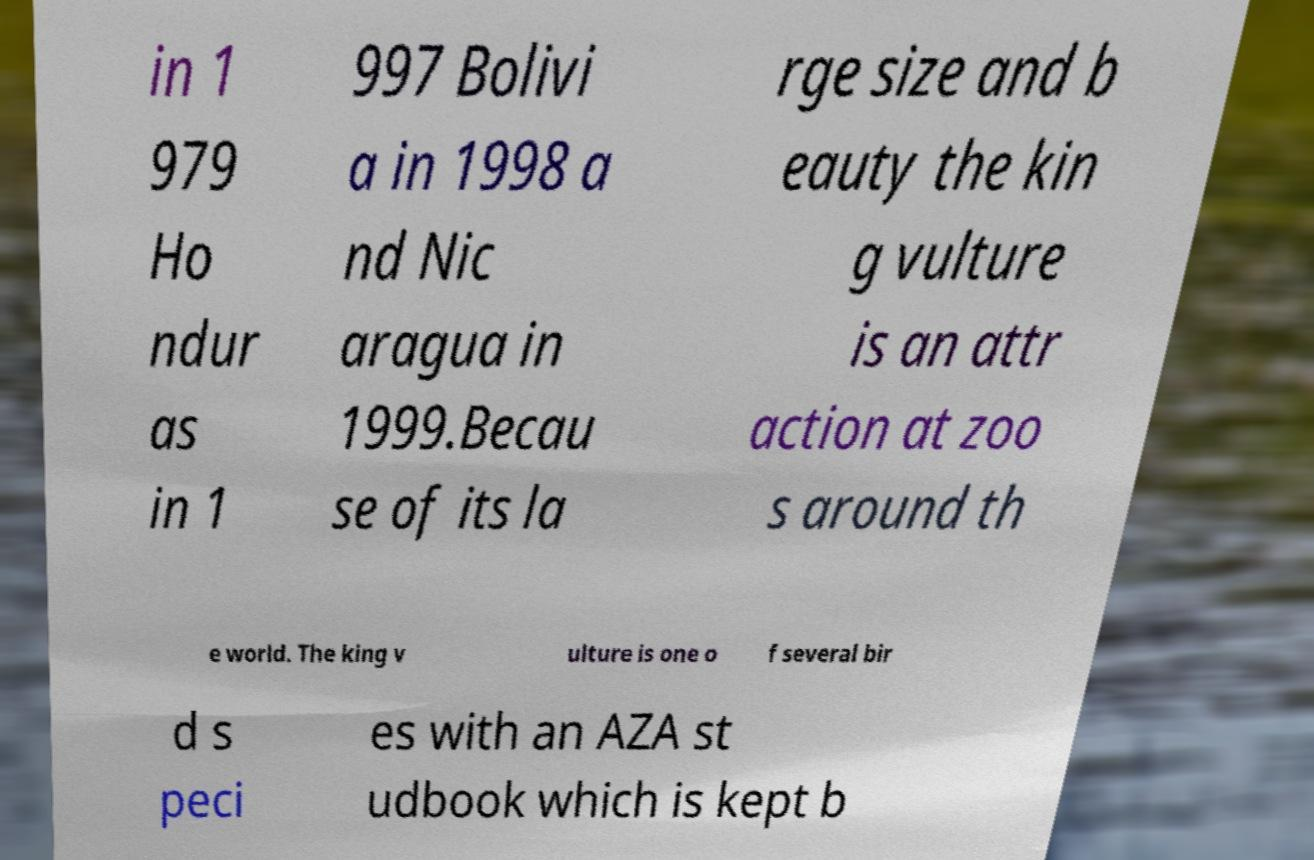Can you accurately transcribe the text from the provided image for me? in 1 979 Ho ndur as in 1 997 Bolivi a in 1998 a nd Nic aragua in 1999.Becau se of its la rge size and b eauty the kin g vulture is an attr action at zoo s around th e world. The king v ulture is one o f several bir d s peci es with an AZA st udbook which is kept b 